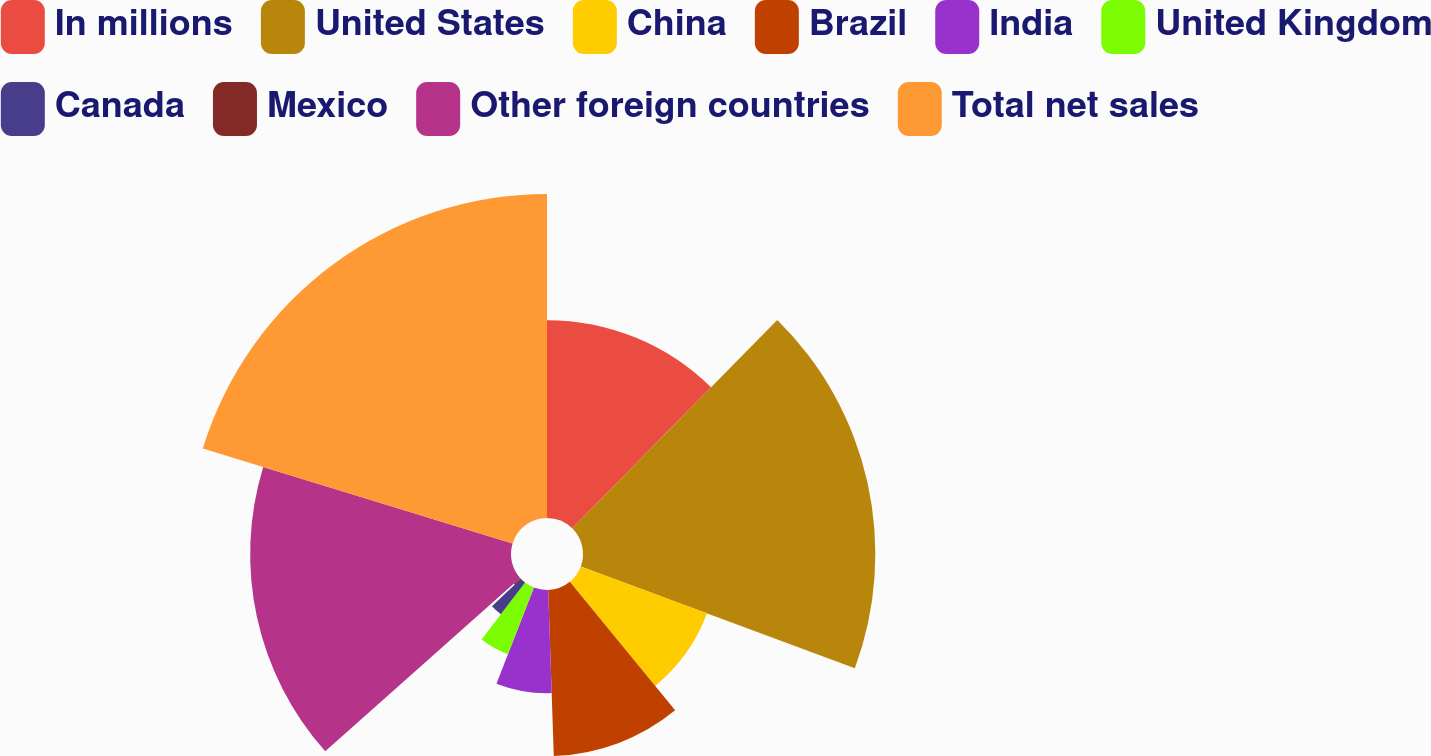Convert chart. <chart><loc_0><loc_0><loc_500><loc_500><pie_chart><fcel>In millions<fcel>United States<fcel>China<fcel>Brazil<fcel>India<fcel>United Kingdom<fcel>Canada<fcel>Mexico<fcel>Other foreign countries<fcel>Total net sales<nl><fcel>12.37%<fcel>18.28%<fcel>8.42%<fcel>10.39%<fcel>6.45%<fcel>4.48%<fcel>2.5%<fcel>0.53%<fcel>16.31%<fcel>20.26%<nl></chart> 